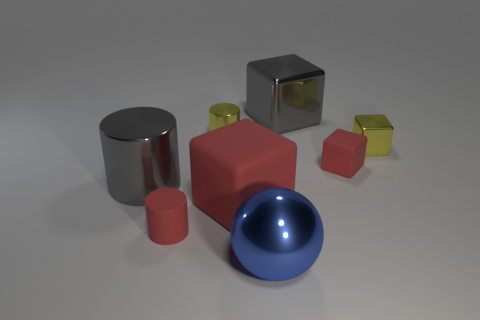Subtract all gray blocks. How many blocks are left? 3 Subtract all red cylinders. How many cylinders are left? 2 Subtract 0 green cylinders. How many objects are left? 8 Subtract all balls. How many objects are left? 7 Subtract 1 balls. How many balls are left? 0 Subtract all red cylinders. Subtract all brown spheres. How many cylinders are left? 2 Subtract all gray cylinders. How many red cubes are left? 2 Subtract all small green metal spheres. Subtract all large blue objects. How many objects are left? 7 Add 8 small yellow objects. How many small yellow objects are left? 10 Add 4 blue shiny things. How many blue shiny things exist? 5 